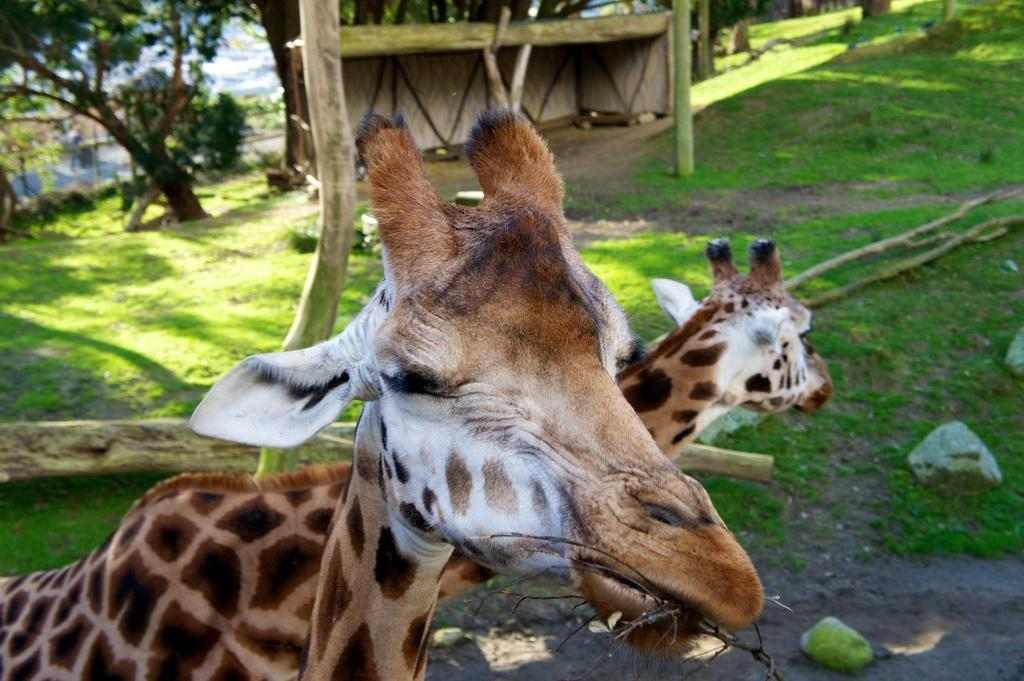How many giraffes are in the image? There are two giraffes in the image. What is on the ground in the image? There is greenery on the ground in the image. What can be seen in the background of the image? There are trees and other objects in the background of the image. What type of destruction can be seen in the image? There is no destruction present in the image; it features two giraffes, greenery, trees, and other objects in the background. Can you tell me which giraffe has a longer toe in the image? Giraffes do not have toes like humans or other animals; they have hooves, and the image does not provide enough detail to compare their lengths. 